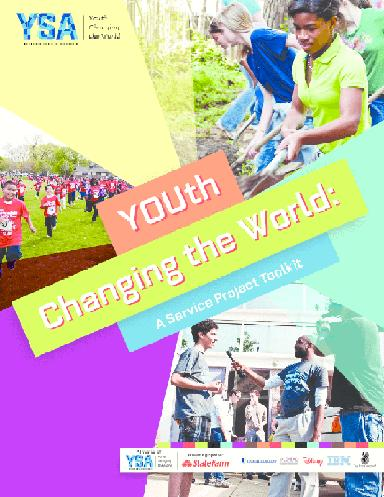What age groups does YSA target with its message? Youth Service America focuses on engaging children and young adults, typically those aged 5 to 25. The key message on the brochure suggests a particular focus on the dynamism and innovative potential of young people to drive societal progress through service and volunteering. 